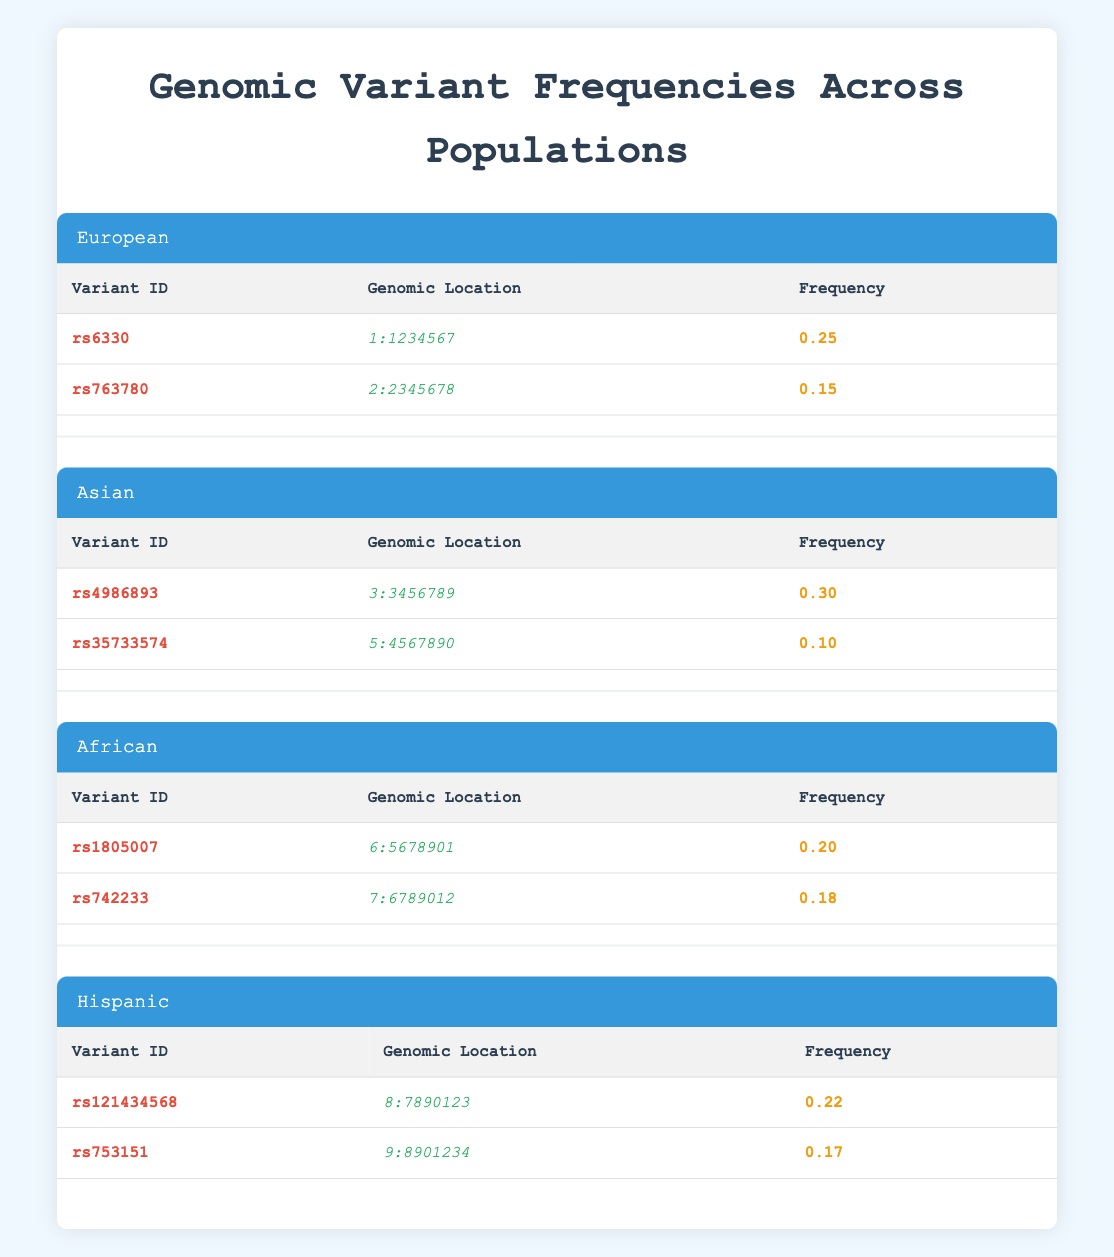What is the frequency of variant rs6330 in the European population? The table lists the frequency of rs6330 under the European population section, which is displayed as 0.25.
Answer: 0.25 Which genomic variant has the highest frequency in the Asian population? The Asian population shows two variants: rs4986893 with a frequency of 0.30 and rs35733574 with a frequency of 0.10. Comparing these, rs4986893 has the highest frequency.
Answer: rs4986893 Is the frequency of rs742233 in the African population greater than 0.20? The table shows that the frequency of rs742233 is 0.18, which is not greater than 0.20.
Answer: No What is the average frequency of variants in the European population? There are two variants in the European population: rs6330 (0.25) and rs763780 (0.15). The average frequency is calculated as (0.25 + 0.15) / 2 = 0.20.
Answer: 0.20 Are there any variants in the Hispanic population with a frequency greater than 0.20? The Hispanic population has rs121434568 (0.22) and rs753151 (0.17). Since 0.22 is greater than 0.20, there is a variant that meets this criterion.
Answer: Yes How does the frequency of the variant rs4986893 in the Asian population compare to that of rs121434568 in the Hispanic population? The frequency of rs4986893 is 0.30, while for rs121434568 it is 0.22. Therefore, 0.30 is greater than 0.22.
Answer: 0.30 is greater What is the total frequency of all variants listed in the African population? The African population has rs1805007 (0.20) and rs742233 (0.18). Adding these gives a total frequency of 0.20 + 0.18 = 0.38.
Answer: 0.38 Is the genomic location of the variant rs763780 located on chromosome 2? The genomic location for rs763780 is listed as 2:2345678, which indicates that it is indeed on chromosome 2.
Answer: Yes Which population has the lowest frequency variant recorded in the table? Evaluating frequencies across all populations: European (0.15), Asian (0.10), African (0.18), and Hispanic (0.17). The lowest frequency is 0.10 from the Asian population.
Answer: Asian population (0.10) 